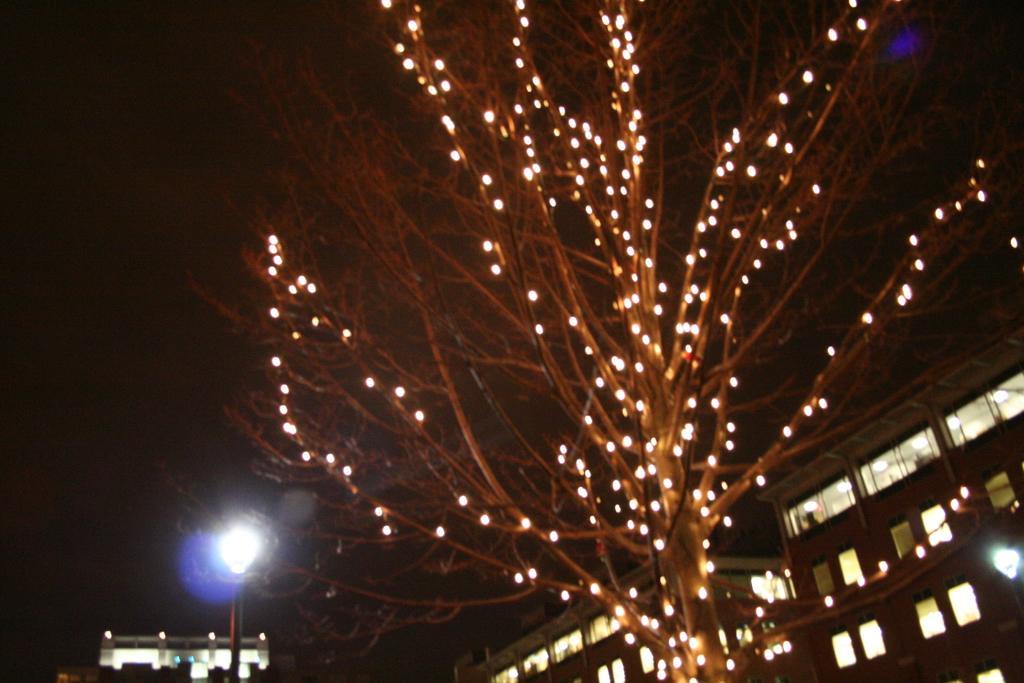Describe this image in one or two sentences. In this image I see the buildings and I see a tree over here on which there are lights and I see the light poles on either sides and it is dark in the background. 